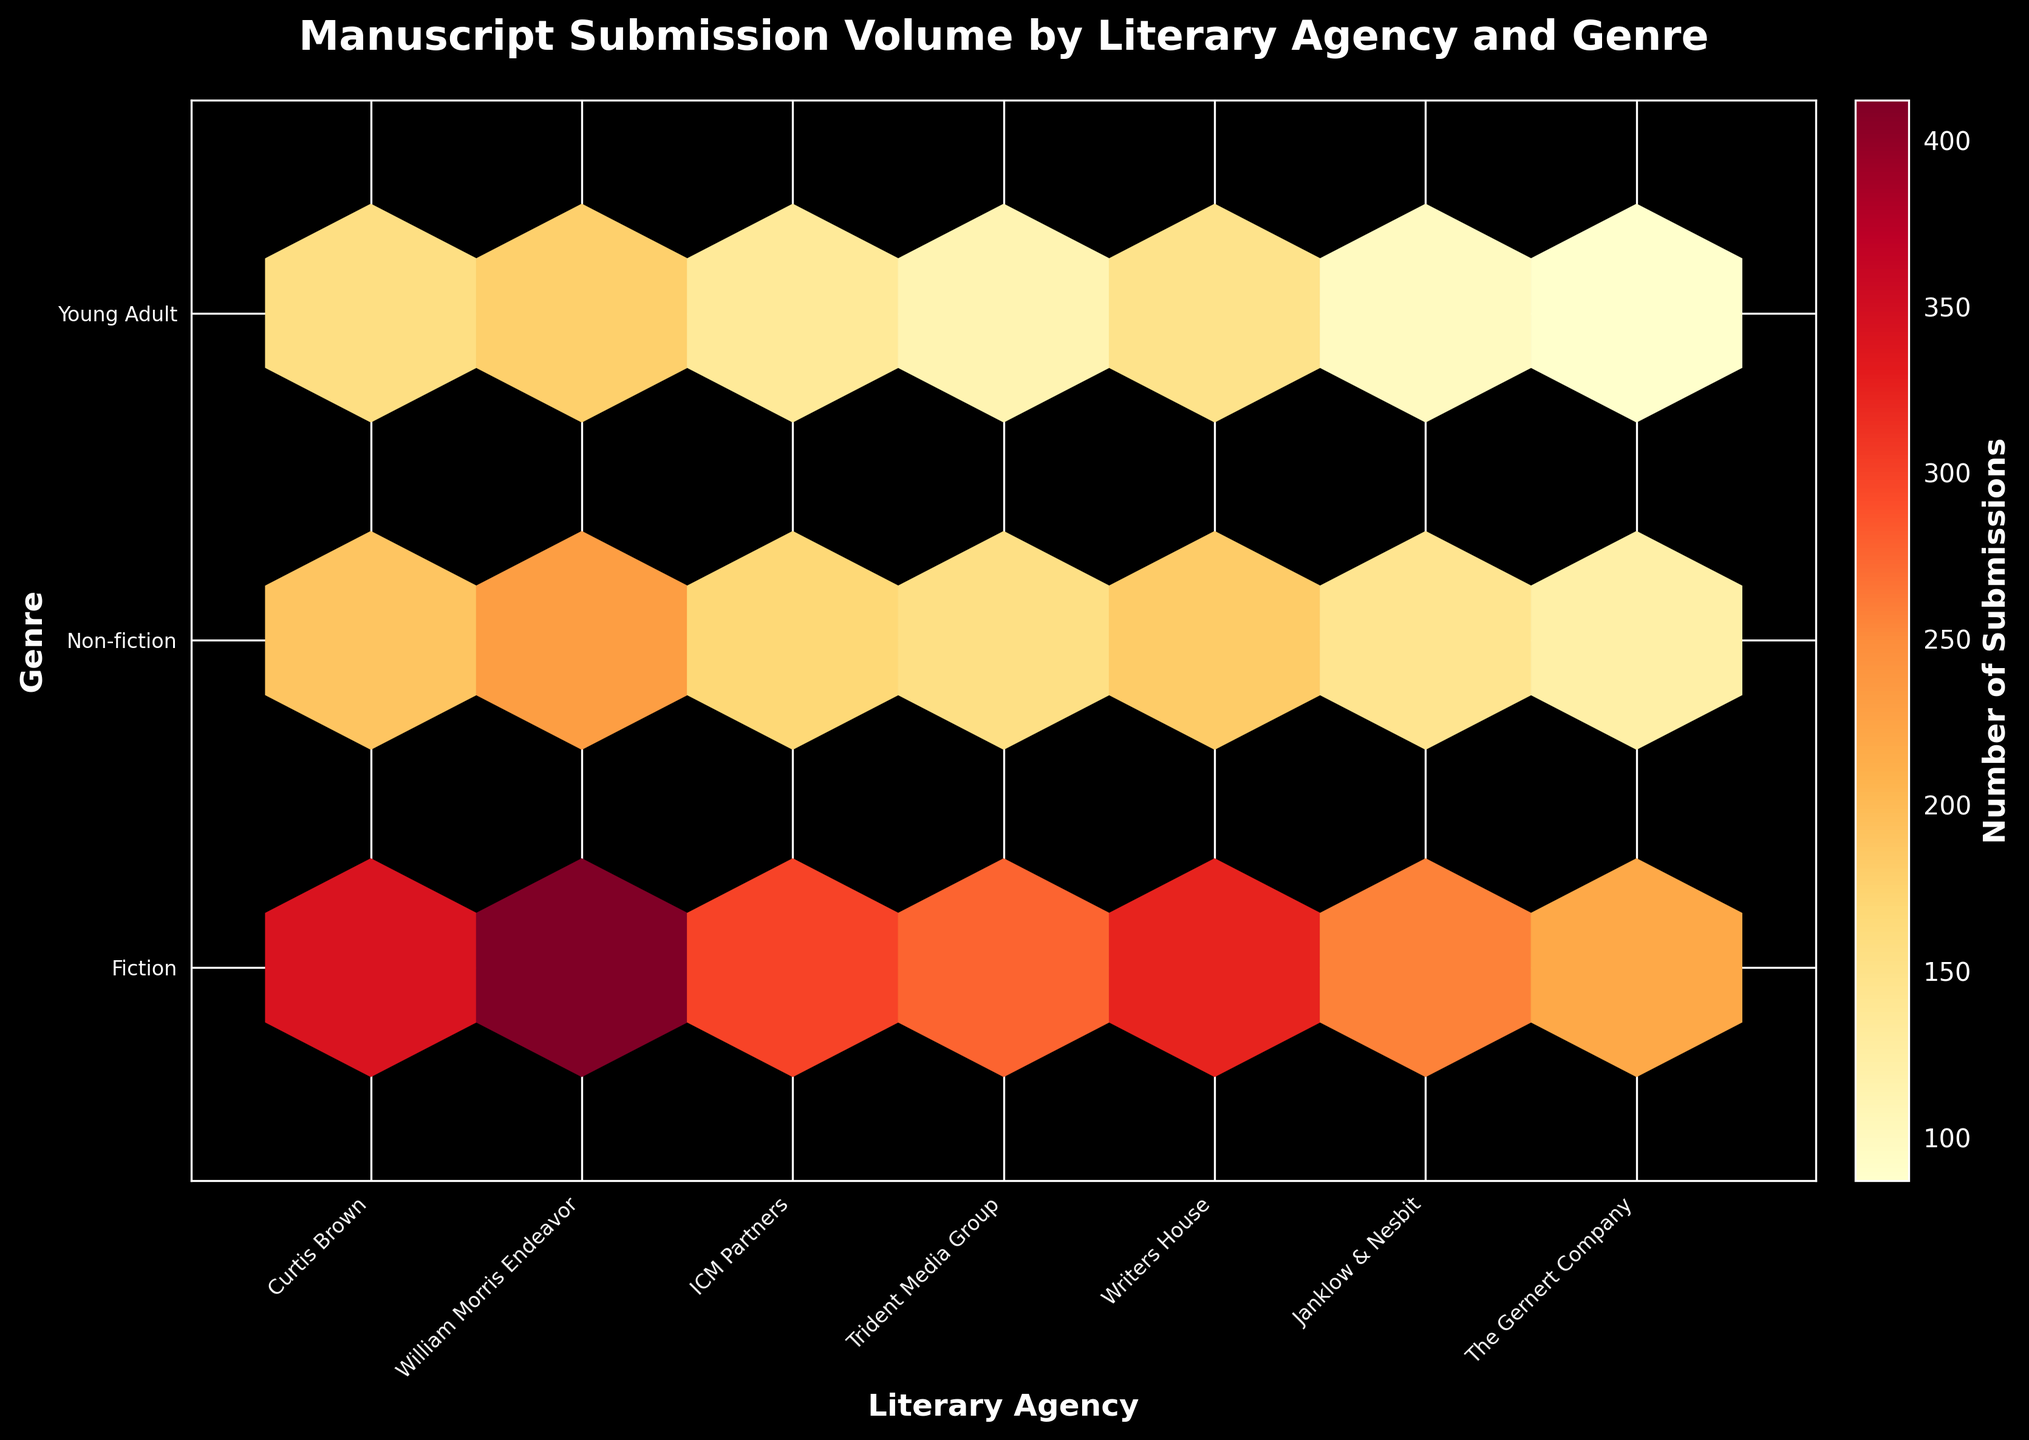What is the title of the plot? The title of the plot is usually displayed at the top of the figure.
Answer: Manuscript Submission Volume by Literary Agency and Genre What are the x-axis and y-axis labels? The x-axis label is at the bottom of the figure and the y-axis label is along the left side.
Answer: Literary Agency and Genre Which literary agency has the highest number of Fiction submissions? Look at the xticks representing the agencies and find the hexbin cell with the highest color intensity for Fiction submissions.
Answer: William Morris Endeavor What genre has the lowest number of submissions for Janklow & Nesbit? Find Janklow & Nesbit along the x-axis and look at the hexbin cells for each genre. The genre with the lightest color indicates the lowest number of submissions.
Answer: Young Adult How many total genres are presented in the plot? Count the number of distinct yticks along the y-axis.
Answer: 3 Which literary agency is represented by the brightest hexbin cell? Identify the hexbin cell with the highest color intensity and correlate it with the relevant literary agency on the x-axis. This cell is typically brighter or more saturated in color.
Answer: William Morris Endeavor What is the range of the color bar? The color bar is often on the right-hand side of the plot and indicates the range of data values.
Answer: Number of Submissions Which genre received the most submissions from Curtis Brown? Find Curtis Brown along the x-axis and compare the color intensities of the hexbin cells corresponding to each genre.
Answer: Fiction Which literary agency has the closest submission count for Young Adult and Non-fiction genres? Find each agency on the x-axis and visually compare the color intensities of the Young Adult and Non-fiction hexbin cells. Look for the pairs with similar color intensities.
Answer: Writers House How does the total number of Fiction submissions compare to the total number of Non-fiction submissions across all agencies? Sum the color intensities of the hexbin cells for Fiction and Non-fiction across all agencies and compare their relative magnitudes.
Answer: Fiction has more submissions than Non-fiction 